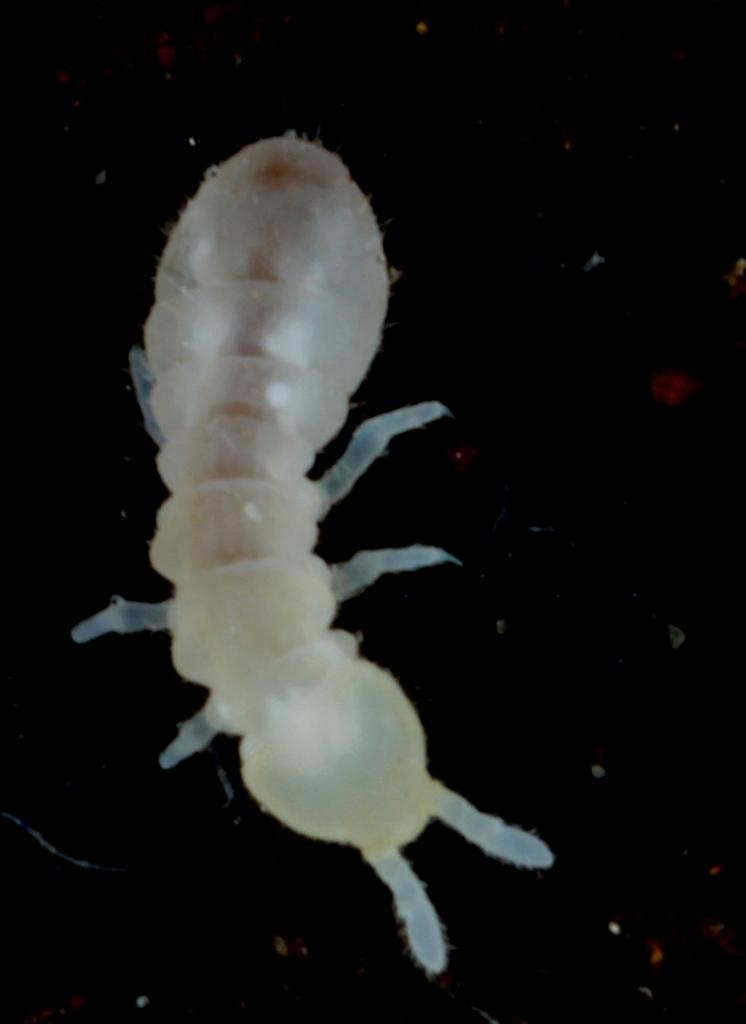What type of creature is present in the image? There is an insect in the image. Can you describe the color of the insect? The insect is white in color. How many pies are being served by the kitten in the image? There is no kitten or pies present in the image; it features a white insect. 